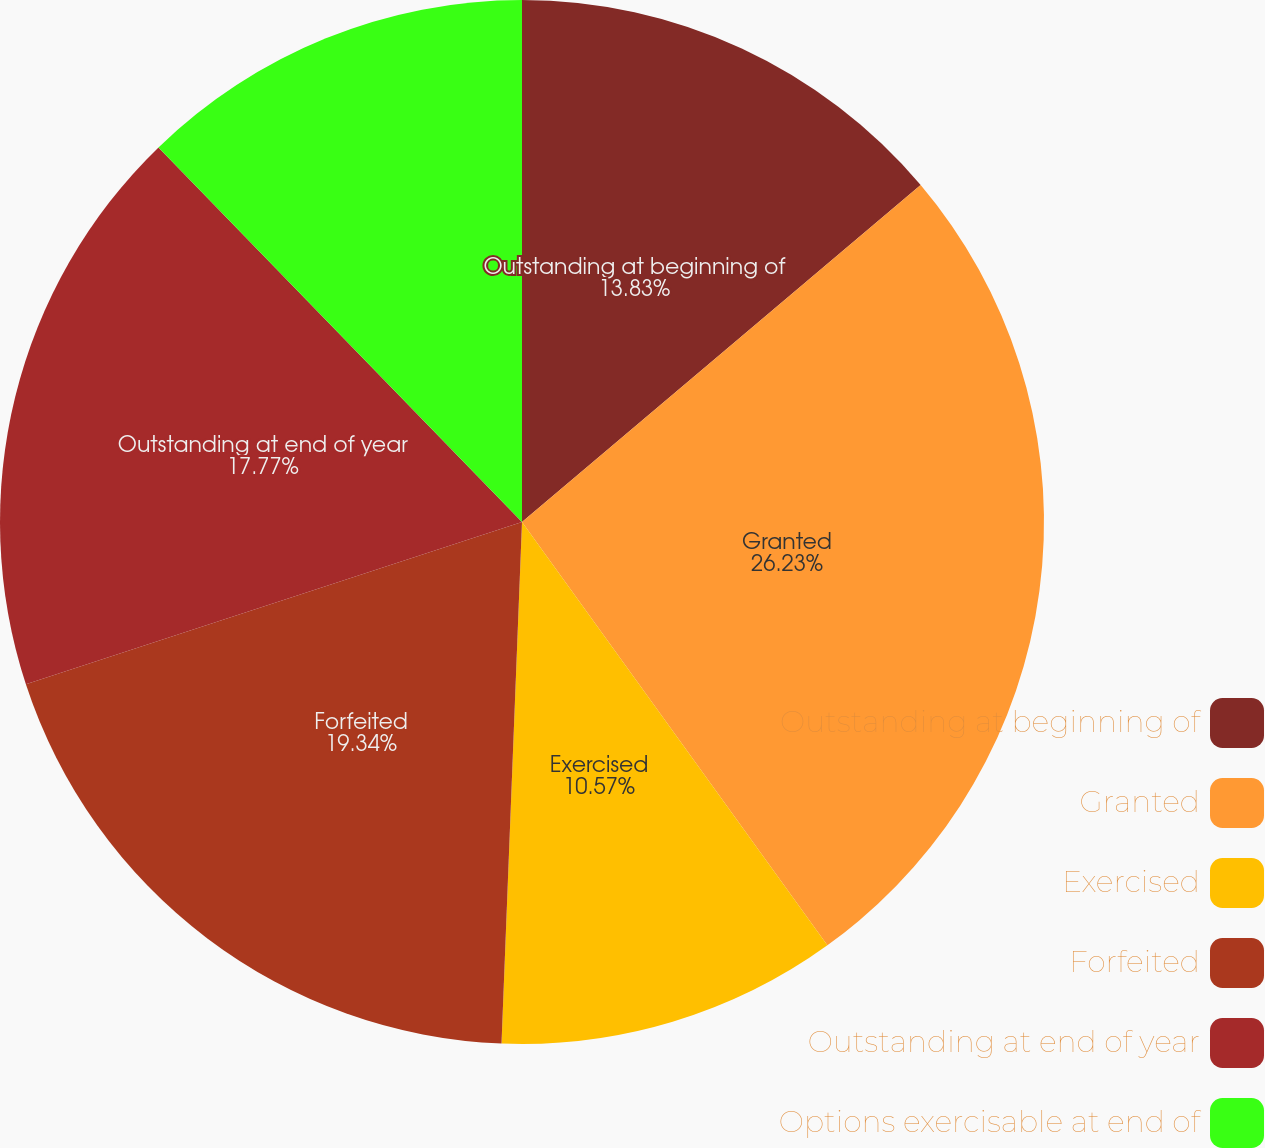Convert chart to OTSL. <chart><loc_0><loc_0><loc_500><loc_500><pie_chart><fcel>Outstanding at beginning of<fcel>Granted<fcel>Exercised<fcel>Forfeited<fcel>Outstanding at end of year<fcel>Options exercisable at end of<nl><fcel>13.83%<fcel>26.22%<fcel>10.57%<fcel>19.34%<fcel>17.77%<fcel>12.26%<nl></chart> 